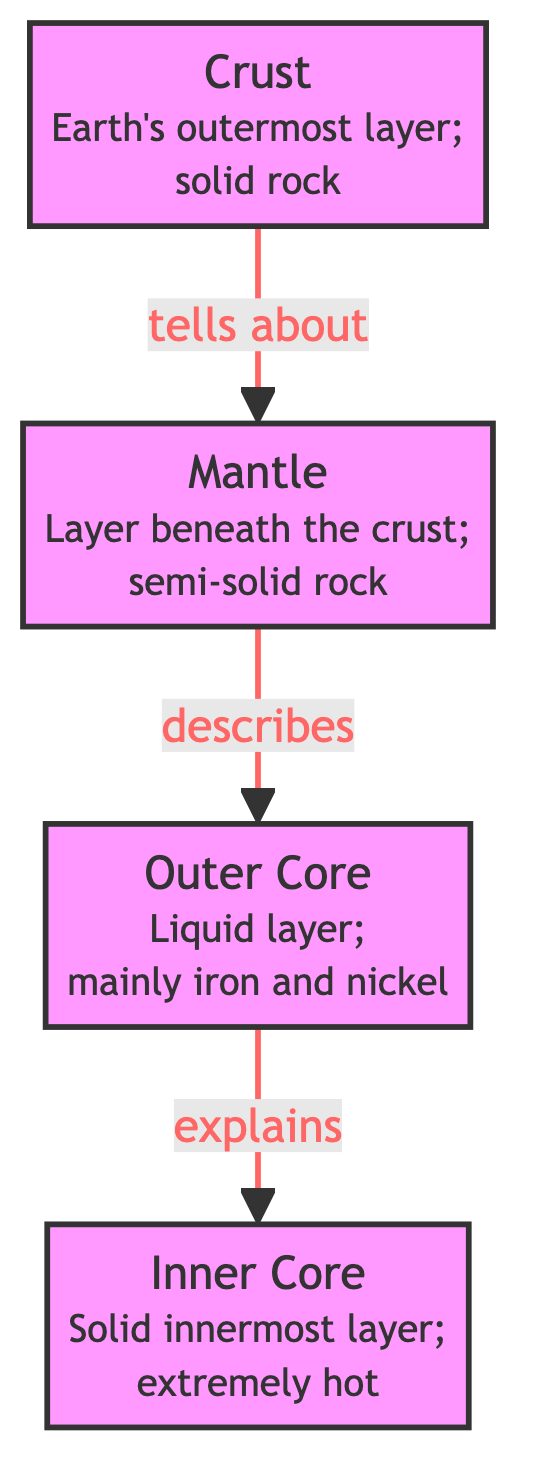What is the outermost layer of the Earth? The diagram indicates that the outermost layer is labeled as "Crust."
Answer: Crust What material mainly composes the outer core? The diagram specifies that the outer core is mainly composed of iron and nickel.
Answer: Iron and nickel What lies directly beneath the crust? From the flow of the diagram, we see an arrow pointing from the crust to the mantle, indicating that the mantle lies directly beneath it.
Answer: Mantle How many layers are presented in the diagram? The diagram shows four distinct layers: crust, mantle, outer core, and inner core. Thus, the total number of layers is four.
Answer: Four What kind of layer is the mantle? The diagram describes the mantle as a "semi-solid rock," which characterizes its type.
Answer: Semi-solid rock Which layer is liquid? According to the diagram, the outer core is designated as a "liquid layer,” indicating that it is the layer in that state.
Answer: Outer Core What is the state of the inner core? The diagram explicitly states that the inner core is a "solid innermost layer," which implies its state.
Answer: Solid Which layer explains the inner core? The arrow in the diagram indicates that the outer core "explains" the inner core, establishing a relationship between them.
Answer: Outer Core What type of structure is this diagram? The diagram falls under the category of a Natural Science Diagram, as it explains the structure of the Earth's layers.
Answer: Natural Science Diagram 